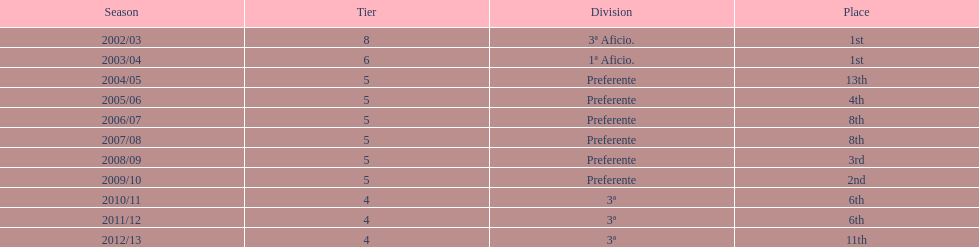How many years was the team in the 3 a division? 4. 